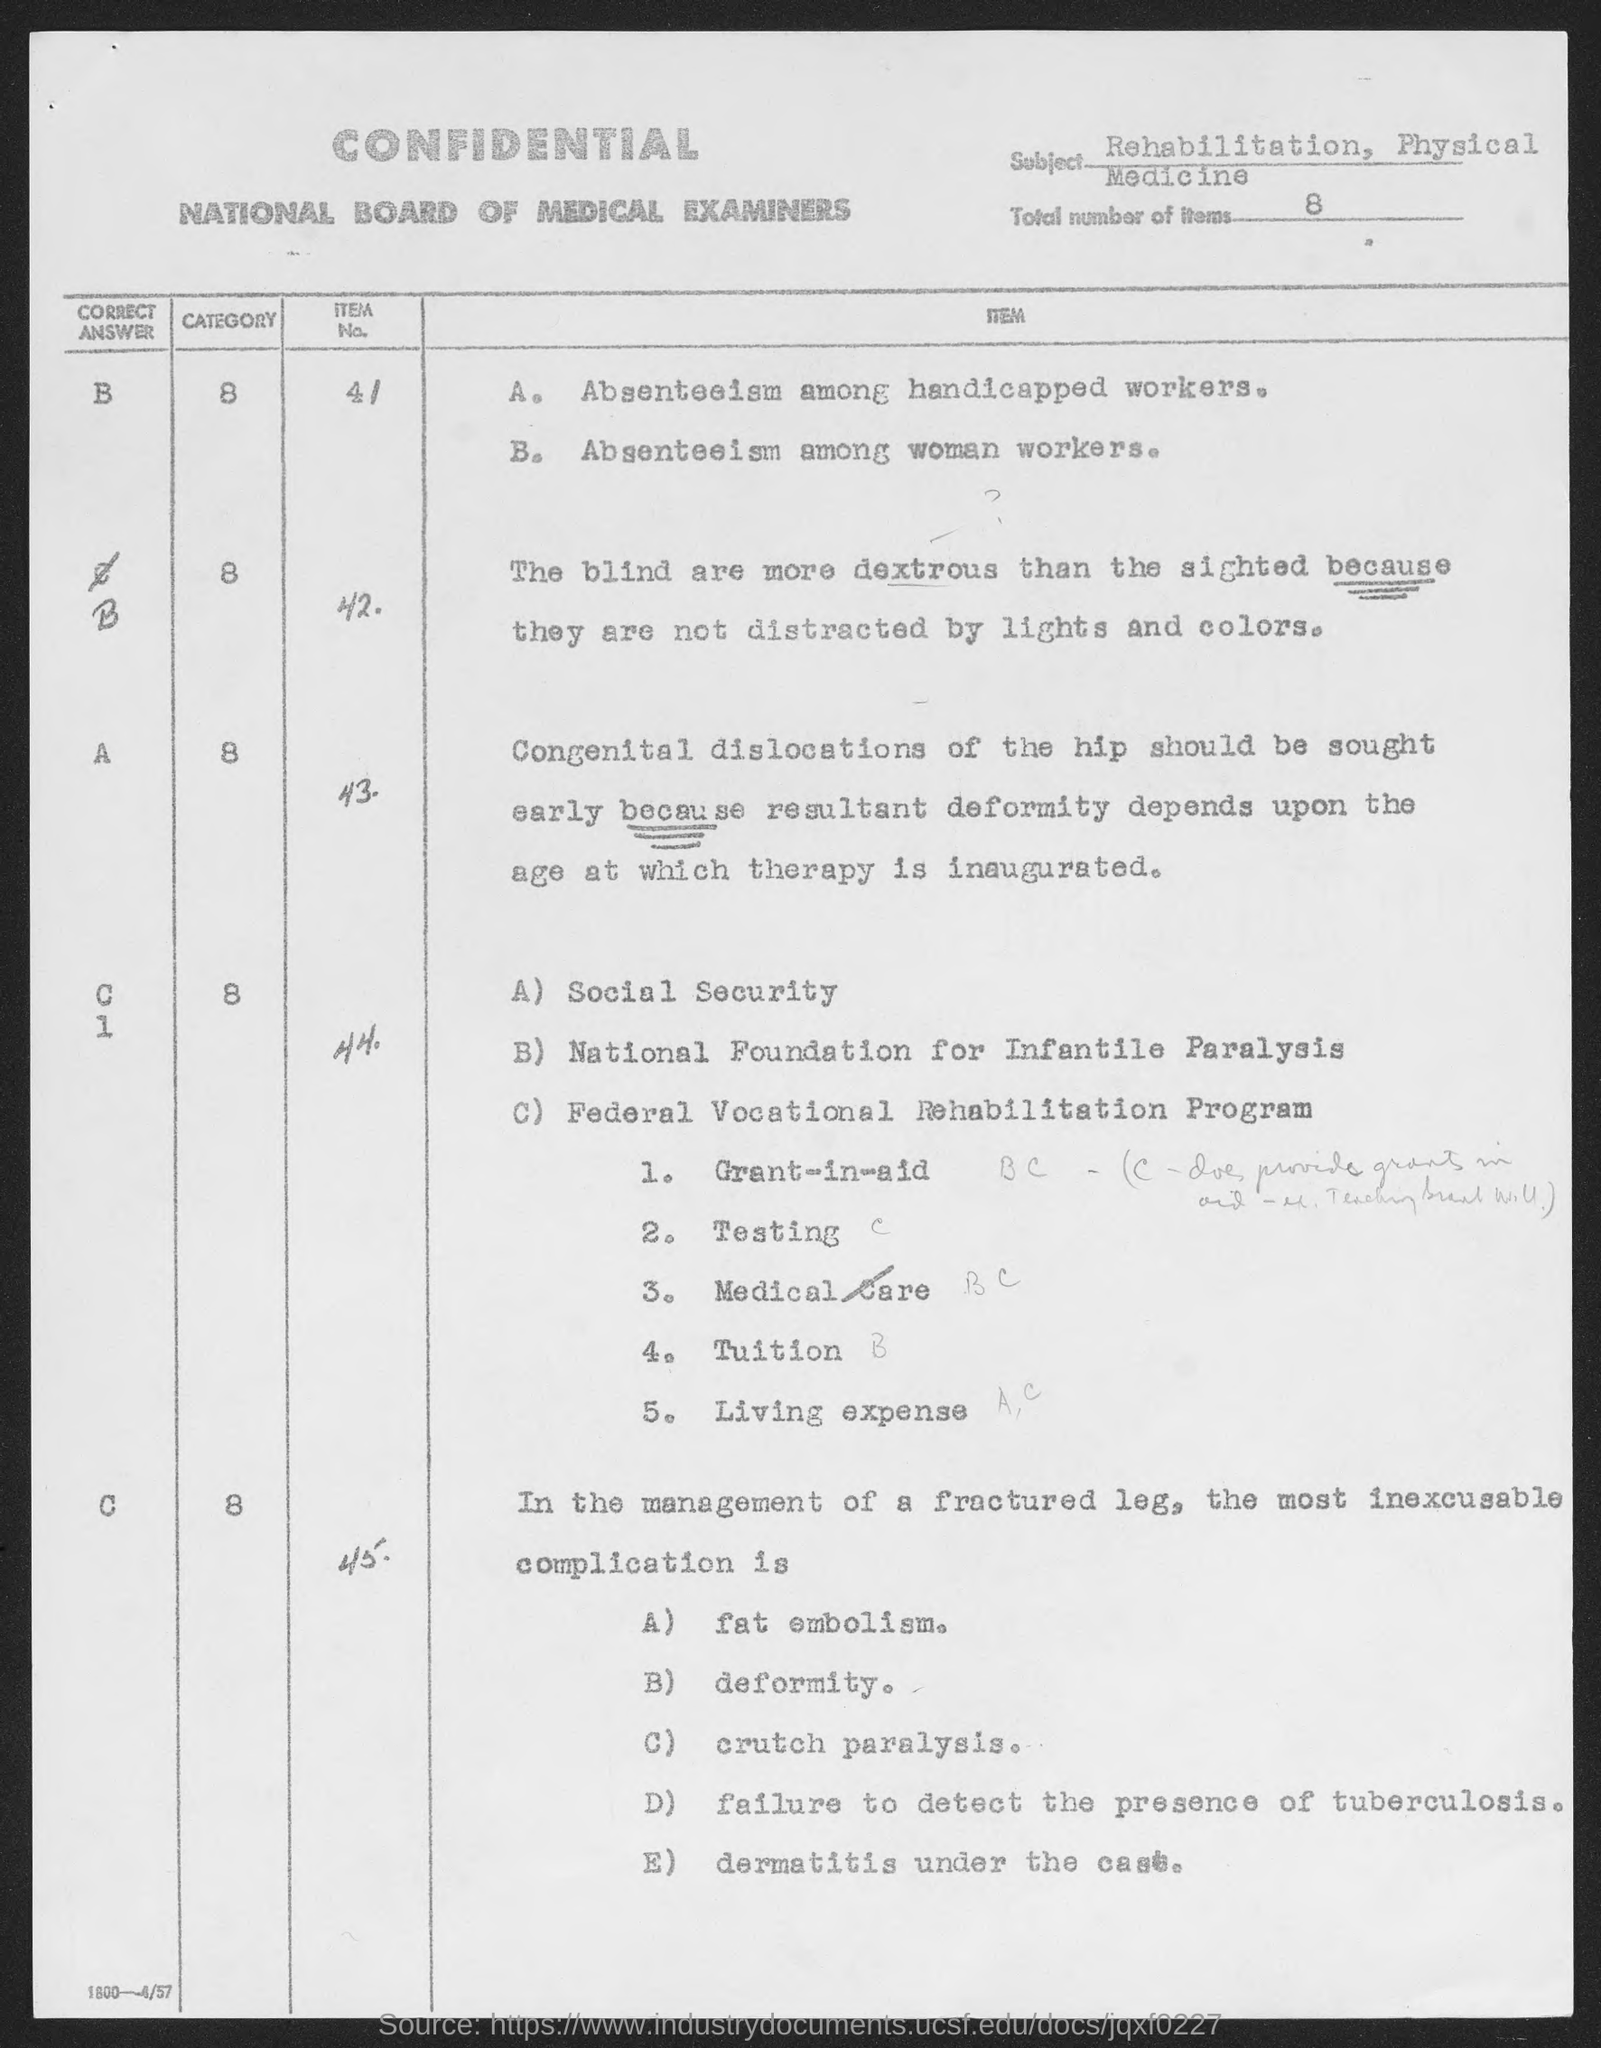Outline some significant characteristics in this image. The subject of the sentence is "Rehabilitation" and "Physical Medicine. The total number of items is 8. 